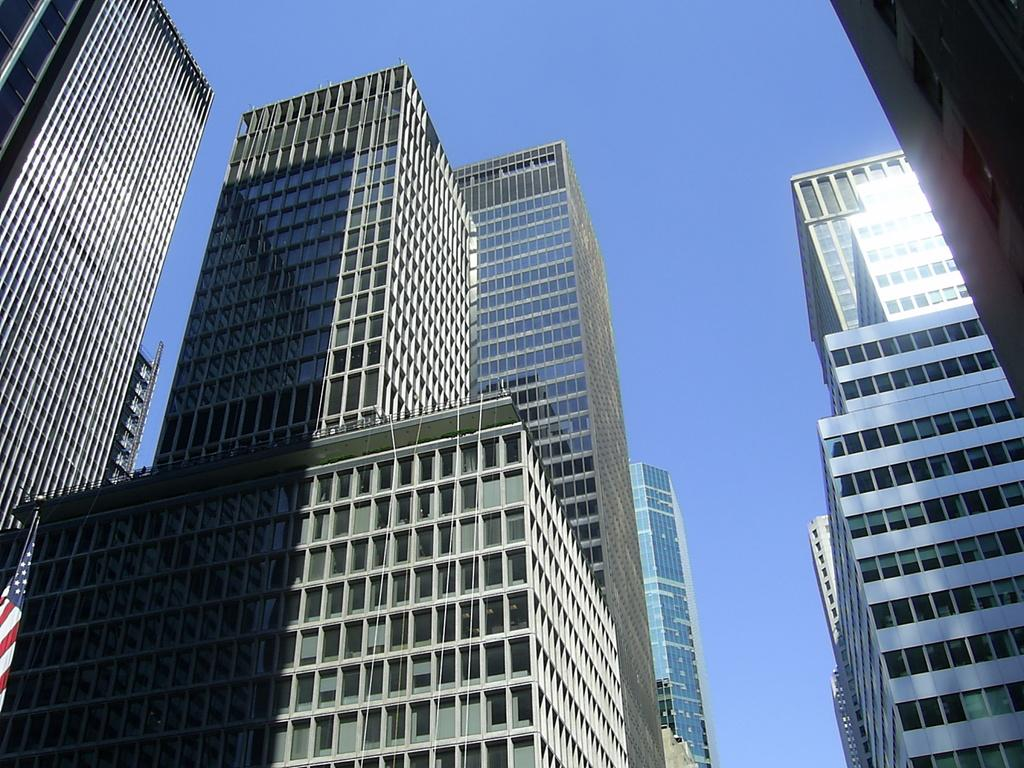What is the main subject of the image? The main subject of the image is a glass building. Where is the image taken from? The image is taken from the outside of the glass building. What can be seen in the background of the image? There is a sky visible in the background of the image. What is located on the left side of the image? There is a flag on the left side of the image. What type of sack can be seen hanging from the flagpole in the image? There is no sack present in the image, and the flagpole is not mentioned in the provided facts. 